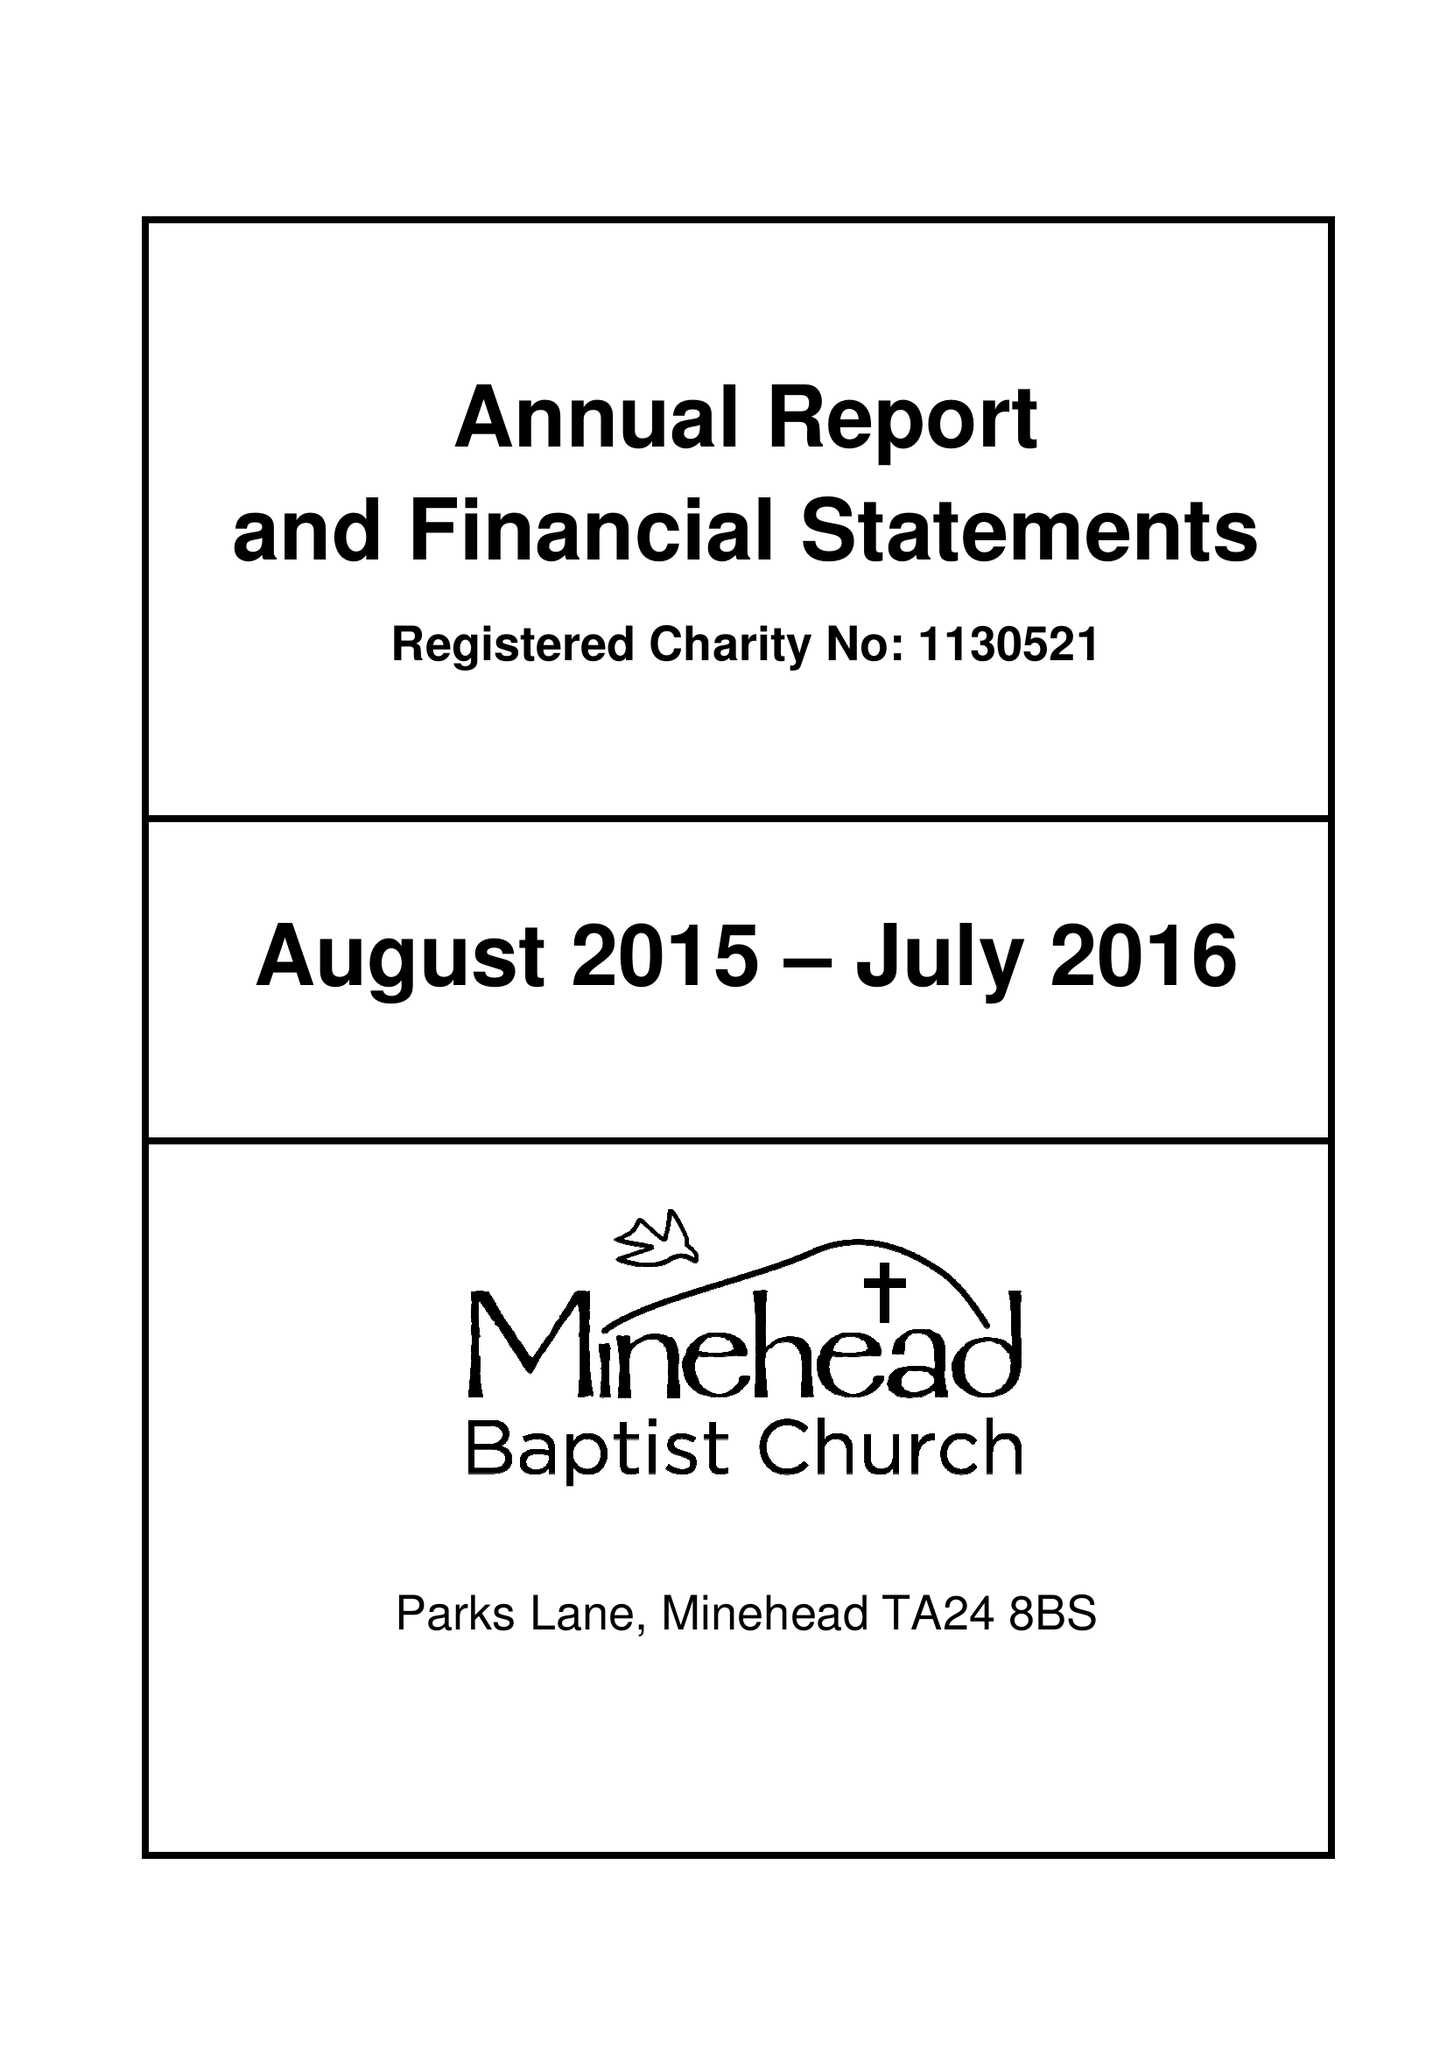What is the value for the charity_name?
Answer the question using a single word or phrase. Minehead Baptist Church 